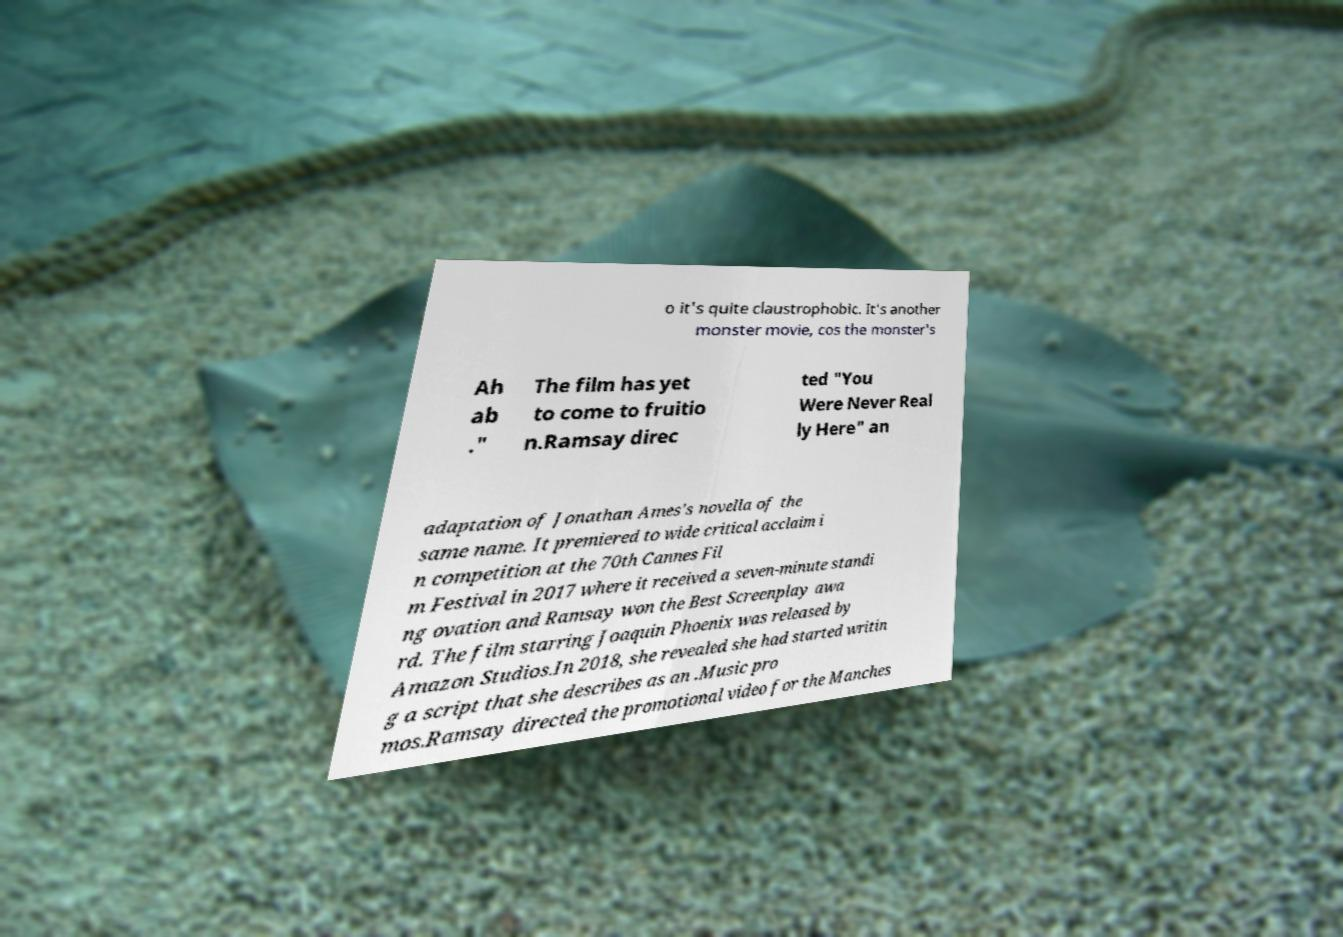Please read and relay the text visible in this image. What does it say? o it's quite claustrophobic. It's another monster movie, cos the monster's Ah ab ." The film has yet to come to fruitio n.Ramsay direc ted "You Were Never Real ly Here" an adaptation of Jonathan Ames's novella of the same name. It premiered to wide critical acclaim i n competition at the 70th Cannes Fil m Festival in 2017 where it received a seven-minute standi ng ovation and Ramsay won the Best Screenplay awa rd. The film starring Joaquin Phoenix was released by Amazon Studios.In 2018, she revealed she had started writin g a script that she describes as an .Music pro mos.Ramsay directed the promotional video for the Manches 